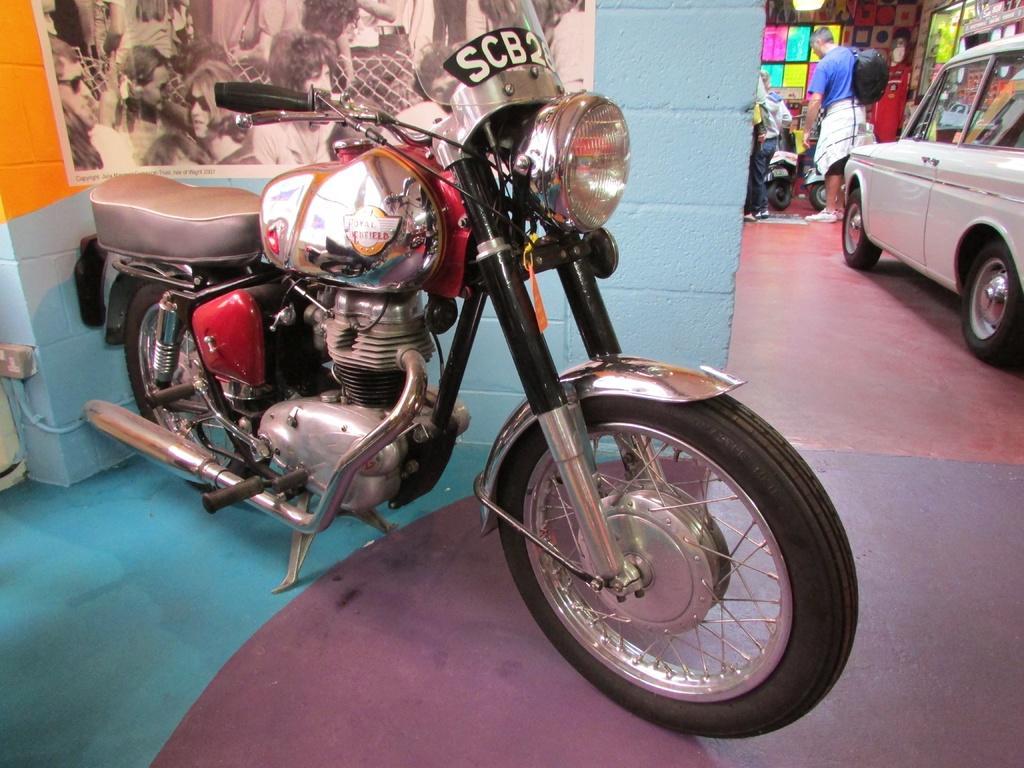Could you give a brief overview of what you see in this image? In this image we can see a motorcycle and behind there is a wall with a poster and on the poster, we can see pictures. On the right side of the image we can see a white car and there are few people and we can see few vehicles in the background. 